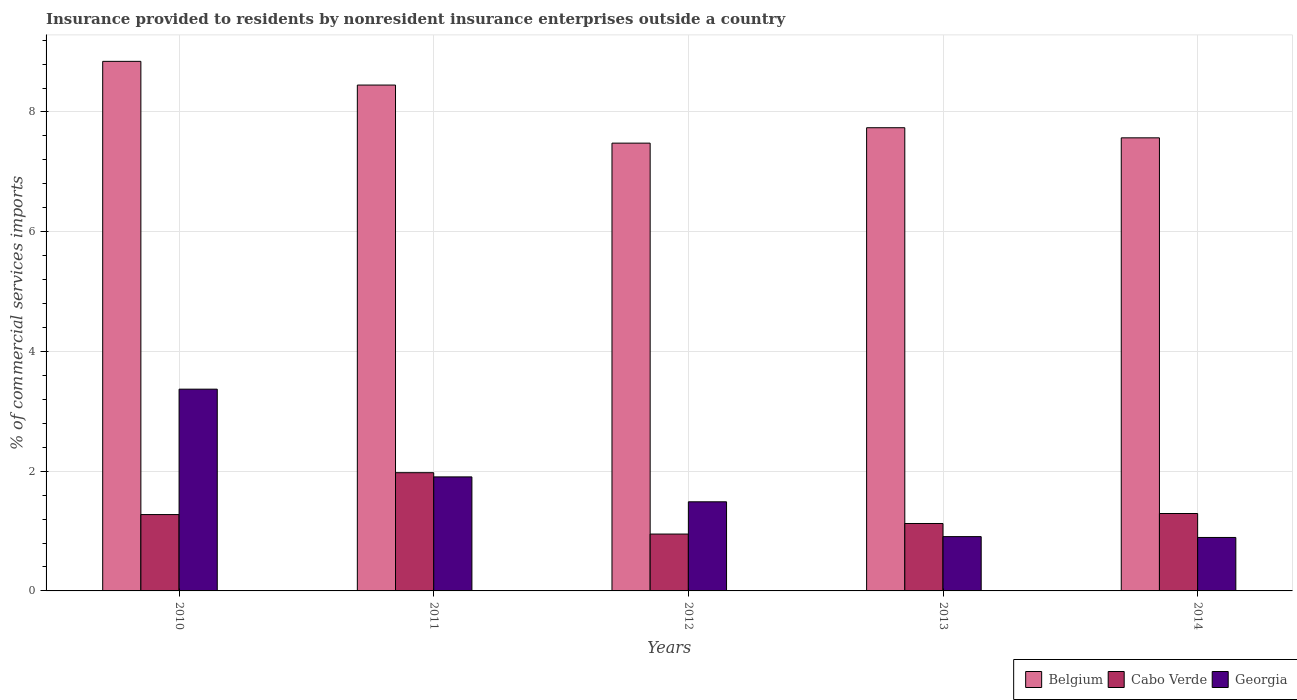How many different coloured bars are there?
Provide a short and direct response. 3. How many groups of bars are there?
Ensure brevity in your answer.  5. Are the number of bars per tick equal to the number of legend labels?
Make the answer very short. Yes. How many bars are there on the 5th tick from the left?
Provide a succinct answer. 3. What is the Insurance provided to residents in Georgia in 2011?
Your answer should be very brief. 1.9. Across all years, what is the maximum Insurance provided to residents in Belgium?
Make the answer very short. 8.85. Across all years, what is the minimum Insurance provided to residents in Georgia?
Your response must be concise. 0.89. What is the total Insurance provided to residents in Belgium in the graph?
Ensure brevity in your answer.  40.08. What is the difference between the Insurance provided to residents in Georgia in 2010 and that in 2011?
Give a very brief answer. 1.47. What is the difference between the Insurance provided to residents in Belgium in 2010 and the Insurance provided to residents in Cabo Verde in 2014?
Offer a very short reply. 7.55. What is the average Insurance provided to residents in Belgium per year?
Give a very brief answer. 8.02. In the year 2012, what is the difference between the Insurance provided to residents in Georgia and Insurance provided to residents in Cabo Verde?
Provide a succinct answer. 0.54. In how many years, is the Insurance provided to residents in Belgium greater than 7.6 %?
Offer a terse response. 3. What is the ratio of the Insurance provided to residents in Georgia in 2012 to that in 2014?
Give a very brief answer. 1.67. Is the difference between the Insurance provided to residents in Georgia in 2011 and 2012 greater than the difference between the Insurance provided to residents in Cabo Verde in 2011 and 2012?
Offer a terse response. No. What is the difference between the highest and the second highest Insurance provided to residents in Belgium?
Your response must be concise. 0.4. What is the difference between the highest and the lowest Insurance provided to residents in Belgium?
Offer a terse response. 1.37. In how many years, is the Insurance provided to residents in Cabo Verde greater than the average Insurance provided to residents in Cabo Verde taken over all years?
Your answer should be very brief. 1. What does the 1st bar from the right in 2014 represents?
Your answer should be compact. Georgia. Is it the case that in every year, the sum of the Insurance provided to residents in Belgium and Insurance provided to residents in Cabo Verde is greater than the Insurance provided to residents in Georgia?
Provide a short and direct response. Yes. Are all the bars in the graph horizontal?
Ensure brevity in your answer.  No. How many years are there in the graph?
Make the answer very short. 5. What is the title of the graph?
Your answer should be compact. Insurance provided to residents by nonresident insurance enterprises outside a country. What is the label or title of the X-axis?
Offer a very short reply. Years. What is the label or title of the Y-axis?
Offer a terse response. % of commercial services imports. What is the % of commercial services imports of Belgium in 2010?
Provide a succinct answer. 8.85. What is the % of commercial services imports in Cabo Verde in 2010?
Give a very brief answer. 1.28. What is the % of commercial services imports of Georgia in 2010?
Ensure brevity in your answer.  3.37. What is the % of commercial services imports of Belgium in 2011?
Your answer should be compact. 8.45. What is the % of commercial services imports in Cabo Verde in 2011?
Your response must be concise. 1.97. What is the % of commercial services imports in Georgia in 2011?
Give a very brief answer. 1.9. What is the % of commercial services imports of Belgium in 2012?
Provide a succinct answer. 7.48. What is the % of commercial services imports of Cabo Verde in 2012?
Your response must be concise. 0.95. What is the % of commercial services imports of Georgia in 2012?
Your answer should be very brief. 1.49. What is the % of commercial services imports of Belgium in 2013?
Ensure brevity in your answer.  7.74. What is the % of commercial services imports of Cabo Verde in 2013?
Your answer should be compact. 1.13. What is the % of commercial services imports of Georgia in 2013?
Your answer should be compact. 0.91. What is the % of commercial services imports of Belgium in 2014?
Your answer should be compact. 7.57. What is the % of commercial services imports in Cabo Verde in 2014?
Your response must be concise. 1.29. What is the % of commercial services imports in Georgia in 2014?
Make the answer very short. 0.89. Across all years, what is the maximum % of commercial services imports of Belgium?
Your response must be concise. 8.85. Across all years, what is the maximum % of commercial services imports in Cabo Verde?
Offer a terse response. 1.97. Across all years, what is the maximum % of commercial services imports in Georgia?
Your answer should be compact. 3.37. Across all years, what is the minimum % of commercial services imports of Belgium?
Your answer should be compact. 7.48. Across all years, what is the minimum % of commercial services imports of Cabo Verde?
Your answer should be very brief. 0.95. Across all years, what is the minimum % of commercial services imports in Georgia?
Offer a very short reply. 0.89. What is the total % of commercial services imports in Belgium in the graph?
Give a very brief answer. 40.08. What is the total % of commercial services imports in Cabo Verde in the graph?
Your response must be concise. 6.62. What is the total % of commercial services imports of Georgia in the graph?
Your response must be concise. 8.56. What is the difference between the % of commercial services imports of Belgium in 2010 and that in 2011?
Make the answer very short. 0.4. What is the difference between the % of commercial services imports in Cabo Verde in 2010 and that in 2011?
Your response must be concise. -0.7. What is the difference between the % of commercial services imports in Georgia in 2010 and that in 2011?
Your answer should be compact. 1.47. What is the difference between the % of commercial services imports of Belgium in 2010 and that in 2012?
Your response must be concise. 1.37. What is the difference between the % of commercial services imports in Cabo Verde in 2010 and that in 2012?
Offer a terse response. 0.33. What is the difference between the % of commercial services imports of Georgia in 2010 and that in 2012?
Provide a succinct answer. 1.88. What is the difference between the % of commercial services imports of Belgium in 2010 and that in 2013?
Make the answer very short. 1.11. What is the difference between the % of commercial services imports of Cabo Verde in 2010 and that in 2013?
Offer a very short reply. 0.15. What is the difference between the % of commercial services imports of Georgia in 2010 and that in 2013?
Make the answer very short. 2.46. What is the difference between the % of commercial services imports of Belgium in 2010 and that in 2014?
Your response must be concise. 1.28. What is the difference between the % of commercial services imports of Cabo Verde in 2010 and that in 2014?
Your response must be concise. -0.02. What is the difference between the % of commercial services imports of Georgia in 2010 and that in 2014?
Provide a succinct answer. 2.48. What is the difference between the % of commercial services imports in Belgium in 2011 and that in 2012?
Provide a succinct answer. 0.97. What is the difference between the % of commercial services imports in Georgia in 2011 and that in 2012?
Make the answer very short. 0.42. What is the difference between the % of commercial services imports of Belgium in 2011 and that in 2013?
Offer a terse response. 0.71. What is the difference between the % of commercial services imports of Cabo Verde in 2011 and that in 2013?
Your answer should be compact. 0.85. What is the difference between the % of commercial services imports of Georgia in 2011 and that in 2013?
Ensure brevity in your answer.  1. What is the difference between the % of commercial services imports of Belgium in 2011 and that in 2014?
Provide a short and direct response. 0.88. What is the difference between the % of commercial services imports of Cabo Verde in 2011 and that in 2014?
Ensure brevity in your answer.  0.68. What is the difference between the % of commercial services imports in Georgia in 2011 and that in 2014?
Offer a very short reply. 1.01. What is the difference between the % of commercial services imports of Belgium in 2012 and that in 2013?
Make the answer very short. -0.26. What is the difference between the % of commercial services imports of Cabo Verde in 2012 and that in 2013?
Your answer should be very brief. -0.18. What is the difference between the % of commercial services imports of Georgia in 2012 and that in 2013?
Offer a very short reply. 0.58. What is the difference between the % of commercial services imports of Belgium in 2012 and that in 2014?
Make the answer very short. -0.09. What is the difference between the % of commercial services imports in Cabo Verde in 2012 and that in 2014?
Make the answer very short. -0.34. What is the difference between the % of commercial services imports in Georgia in 2012 and that in 2014?
Provide a short and direct response. 0.6. What is the difference between the % of commercial services imports in Belgium in 2013 and that in 2014?
Your answer should be compact. 0.17. What is the difference between the % of commercial services imports of Cabo Verde in 2013 and that in 2014?
Your answer should be very brief. -0.17. What is the difference between the % of commercial services imports of Georgia in 2013 and that in 2014?
Keep it short and to the point. 0.01. What is the difference between the % of commercial services imports of Belgium in 2010 and the % of commercial services imports of Cabo Verde in 2011?
Provide a succinct answer. 6.87. What is the difference between the % of commercial services imports of Belgium in 2010 and the % of commercial services imports of Georgia in 2011?
Make the answer very short. 6.94. What is the difference between the % of commercial services imports in Cabo Verde in 2010 and the % of commercial services imports in Georgia in 2011?
Provide a succinct answer. -0.63. What is the difference between the % of commercial services imports of Belgium in 2010 and the % of commercial services imports of Cabo Verde in 2012?
Offer a terse response. 7.9. What is the difference between the % of commercial services imports in Belgium in 2010 and the % of commercial services imports in Georgia in 2012?
Ensure brevity in your answer.  7.36. What is the difference between the % of commercial services imports in Cabo Verde in 2010 and the % of commercial services imports in Georgia in 2012?
Your response must be concise. -0.21. What is the difference between the % of commercial services imports of Belgium in 2010 and the % of commercial services imports of Cabo Verde in 2013?
Your answer should be compact. 7.72. What is the difference between the % of commercial services imports in Belgium in 2010 and the % of commercial services imports in Georgia in 2013?
Your response must be concise. 7.94. What is the difference between the % of commercial services imports of Cabo Verde in 2010 and the % of commercial services imports of Georgia in 2013?
Your response must be concise. 0.37. What is the difference between the % of commercial services imports of Belgium in 2010 and the % of commercial services imports of Cabo Verde in 2014?
Provide a succinct answer. 7.55. What is the difference between the % of commercial services imports of Belgium in 2010 and the % of commercial services imports of Georgia in 2014?
Your answer should be compact. 7.95. What is the difference between the % of commercial services imports of Cabo Verde in 2010 and the % of commercial services imports of Georgia in 2014?
Your answer should be very brief. 0.38. What is the difference between the % of commercial services imports of Belgium in 2011 and the % of commercial services imports of Cabo Verde in 2012?
Provide a short and direct response. 7.5. What is the difference between the % of commercial services imports of Belgium in 2011 and the % of commercial services imports of Georgia in 2012?
Offer a very short reply. 6.96. What is the difference between the % of commercial services imports of Cabo Verde in 2011 and the % of commercial services imports of Georgia in 2012?
Give a very brief answer. 0.49. What is the difference between the % of commercial services imports in Belgium in 2011 and the % of commercial services imports in Cabo Verde in 2013?
Offer a terse response. 7.32. What is the difference between the % of commercial services imports in Belgium in 2011 and the % of commercial services imports in Georgia in 2013?
Give a very brief answer. 7.54. What is the difference between the % of commercial services imports in Cabo Verde in 2011 and the % of commercial services imports in Georgia in 2013?
Provide a short and direct response. 1.07. What is the difference between the % of commercial services imports of Belgium in 2011 and the % of commercial services imports of Cabo Verde in 2014?
Ensure brevity in your answer.  7.16. What is the difference between the % of commercial services imports of Belgium in 2011 and the % of commercial services imports of Georgia in 2014?
Give a very brief answer. 7.56. What is the difference between the % of commercial services imports in Cabo Verde in 2011 and the % of commercial services imports in Georgia in 2014?
Make the answer very short. 1.08. What is the difference between the % of commercial services imports of Belgium in 2012 and the % of commercial services imports of Cabo Verde in 2013?
Make the answer very short. 6.35. What is the difference between the % of commercial services imports in Belgium in 2012 and the % of commercial services imports in Georgia in 2013?
Provide a succinct answer. 6.57. What is the difference between the % of commercial services imports of Cabo Verde in 2012 and the % of commercial services imports of Georgia in 2013?
Ensure brevity in your answer.  0.04. What is the difference between the % of commercial services imports in Belgium in 2012 and the % of commercial services imports in Cabo Verde in 2014?
Your response must be concise. 6.19. What is the difference between the % of commercial services imports of Belgium in 2012 and the % of commercial services imports of Georgia in 2014?
Make the answer very short. 6.59. What is the difference between the % of commercial services imports of Cabo Verde in 2012 and the % of commercial services imports of Georgia in 2014?
Make the answer very short. 0.06. What is the difference between the % of commercial services imports in Belgium in 2013 and the % of commercial services imports in Cabo Verde in 2014?
Your answer should be very brief. 6.44. What is the difference between the % of commercial services imports in Belgium in 2013 and the % of commercial services imports in Georgia in 2014?
Your response must be concise. 6.84. What is the difference between the % of commercial services imports of Cabo Verde in 2013 and the % of commercial services imports of Georgia in 2014?
Your answer should be very brief. 0.23. What is the average % of commercial services imports in Belgium per year?
Give a very brief answer. 8.02. What is the average % of commercial services imports in Cabo Verde per year?
Your answer should be compact. 1.32. What is the average % of commercial services imports in Georgia per year?
Provide a short and direct response. 1.71. In the year 2010, what is the difference between the % of commercial services imports of Belgium and % of commercial services imports of Cabo Verde?
Your answer should be very brief. 7.57. In the year 2010, what is the difference between the % of commercial services imports of Belgium and % of commercial services imports of Georgia?
Keep it short and to the point. 5.48. In the year 2010, what is the difference between the % of commercial services imports of Cabo Verde and % of commercial services imports of Georgia?
Offer a terse response. -2.09. In the year 2011, what is the difference between the % of commercial services imports of Belgium and % of commercial services imports of Cabo Verde?
Provide a short and direct response. 6.47. In the year 2011, what is the difference between the % of commercial services imports of Belgium and % of commercial services imports of Georgia?
Make the answer very short. 6.55. In the year 2011, what is the difference between the % of commercial services imports of Cabo Verde and % of commercial services imports of Georgia?
Make the answer very short. 0.07. In the year 2012, what is the difference between the % of commercial services imports in Belgium and % of commercial services imports in Cabo Verde?
Provide a short and direct response. 6.53. In the year 2012, what is the difference between the % of commercial services imports in Belgium and % of commercial services imports in Georgia?
Offer a terse response. 5.99. In the year 2012, what is the difference between the % of commercial services imports in Cabo Verde and % of commercial services imports in Georgia?
Keep it short and to the point. -0.54. In the year 2013, what is the difference between the % of commercial services imports in Belgium and % of commercial services imports in Cabo Verde?
Your answer should be compact. 6.61. In the year 2013, what is the difference between the % of commercial services imports in Belgium and % of commercial services imports in Georgia?
Your response must be concise. 6.83. In the year 2013, what is the difference between the % of commercial services imports in Cabo Verde and % of commercial services imports in Georgia?
Provide a succinct answer. 0.22. In the year 2014, what is the difference between the % of commercial services imports in Belgium and % of commercial services imports in Cabo Verde?
Provide a succinct answer. 6.27. In the year 2014, what is the difference between the % of commercial services imports in Belgium and % of commercial services imports in Georgia?
Offer a very short reply. 6.67. In the year 2014, what is the difference between the % of commercial services imports in Cabo Verde and % of commercial services imports in Georgia?
Provide a succinct answer. 0.4. What is the ratio of the % of commercial services imports of Belgium in 2010 to that in 2011?
Make the answer very short. 1.05. What is the ratio of the % of commercial services imports of Cabo Verde in 2010 to that in 2011?
Keep it short and to the point. 0.65. What is the ratio of the % of commercial services imports of Georgia in 2010 to that in 2011?
Offer a terse response. 1.77. What is the ratio of the % of commercial services imports of Belgium in 2010 to that in 2012?
Offer a very short reply. 1.18. What is the ratio of the % of commercial services imports in Cabo Verde in 2010 to that in 2012?
Provide a short and direct response. 1.34. What is the ratio of the % of commercial services imports in Georgia in 2010 to that in 2012?
Your answer should be very brief. 2.26. What is the ratio of the % of commercial services imports in Belgium in 2010 to that in 2013?
Keep it short and to the point. 1.14. What is the ratio of the % of commercial services imports of Cabo Verde in 2010 to that in 2013?
Keep it short and to the point. 1.13. What is the ratio of the % of commercial services imports in Georgia in 2010 to that in 2013?
Offer a terse response. 3.71. What is the ratio of the % of commercial services imports of Belgium in 2010 to that in 2014?
Offer a very short reply. 1.17. What is the ratio of the % of commercial services imports in Cabo Verde in 2010 to that in 2014?
Your answer should be very brief. 0.99. What is the ratio of the % of commercial services imports of Georgia in 2010 to that in 2014?
Your response must be concise. 3.77. What is the ratio of the % of commercial services imports of Belgium in 2011 to that in 2012?
Make the answer very short. 1.13. What is the ratio of the % of commercial services imports of Cabo Verde in 2011 to that in 2012?
Offer a very short reply. 2.08. What is the ratio of the % of commercial services imports of Georgia in 2011 to that in 2012?
Offer a terse response. 1.28. What is the ratio of the % of commercial services imports in Belgium in 2011 to that in 2013?
Make the answer very short. 1.09. What is the ratio of the % of commercial services imports in Cabo Verde in 2011 to that in 2013?
Ensure brevity in your answer.  1.75. What is the ratio of the % of commercial services imports in Georgia in 2011 to that in 2013?
Make the answer very short. 2.1. What is the ratio of the % of commercial services imports of Belgium in 2011 to that in 2014?
Your answer should be compact. 1.12. What is the ratio of the % of commercial services imports in Cabo Verde in 2011 to that in 2014?
Provide a succinct answer. 1.53. What is the ratio of the % of commercial services imports in Georgia in 2011 to that in 2014?
Give a very brief answer. 2.13. What is the ratio of the % of commercial services imports of Belgium in 2012 to that in 2013?
Offer a terse response. 0.97. What is the ratio of the % of commercial services imports in Cabo Verde in 2012 to that in 2013?
Make the answer very short. 0.84. What is the ratio of the % of commercial services imports in Georgia in 2012 to that in 2013?
Make the answer very short. 1.64. What is the ratio of the % of commercial services imports of Belgium in 2012 to that in 2014?
Offer a very short reply. 0.99. What is the ratio of the % of commercial services imports of Cabo Verde in 2012 to that in 2014?
Make the answer very short. 0.73. What is the ratio of the % of commercial services imports of Georgia in 2012 to that in 2014?
Offer a very short reply. 1.67. What is the ratio of the % of commercial services imports in Belgium in 2013 to that in 2014?
Your answer should be compact. 1.02. What is the ratio of the % of commercial services imports of Cabo Verde in 2013 to that in 2014?
Provide a succinct answer. 0.87. What is the difference between the highest and the second highest % of commercial services imports of Belgium?
Your response must be concise. 0.4. What is the difference between the highest and the second highest % of commercial services imports in Cabo Verde?
Offer a terse response. 0.68. What is the difference between the highest and the second highest % of commercial services imports in Georgia?
Give a very brief answer. 1.47. What is the difference between the highest and the lowest % of commercial services imports in Belgium?
Offer a very short reply. 1.37. What is the difference between the highest and the lowest % of commercial services imports in Georgia?
Offer a terse response. 2.48. 